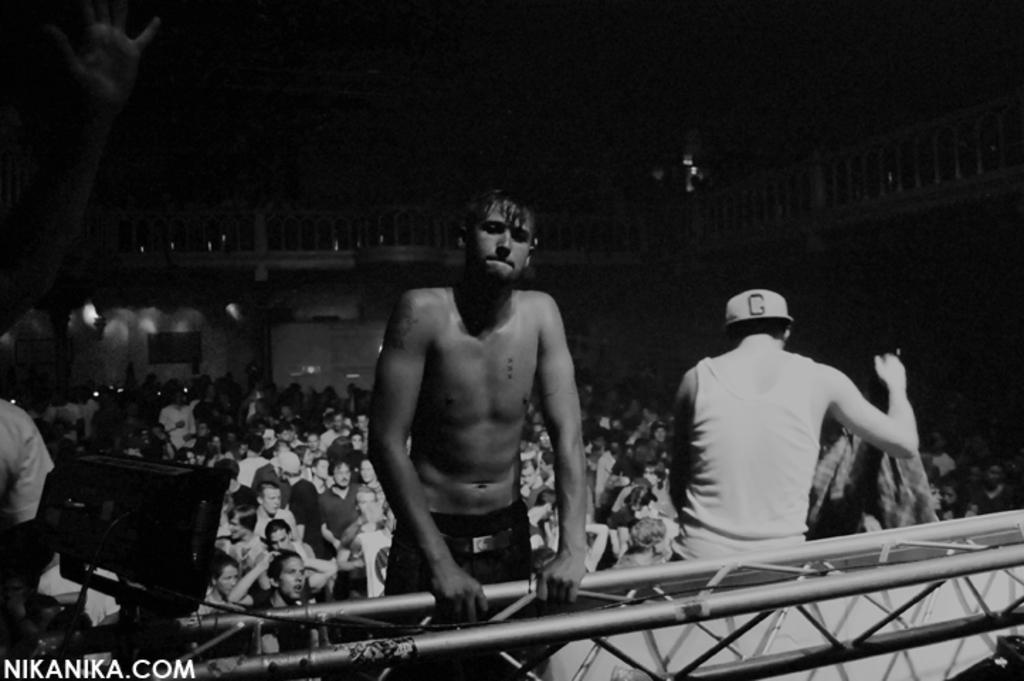What is the color scheme of the image? The image is black and white. What is the shirtless man doing in the image? The shirtless man is holding a metal rod in the image. How many people are present in the image? There are many people standing in the image. What type of club is the shirtless man using to hit the sack in the image? There is no club or sack present in the image; it features a shirtless man holding a metal rod and many people standing nearby. 